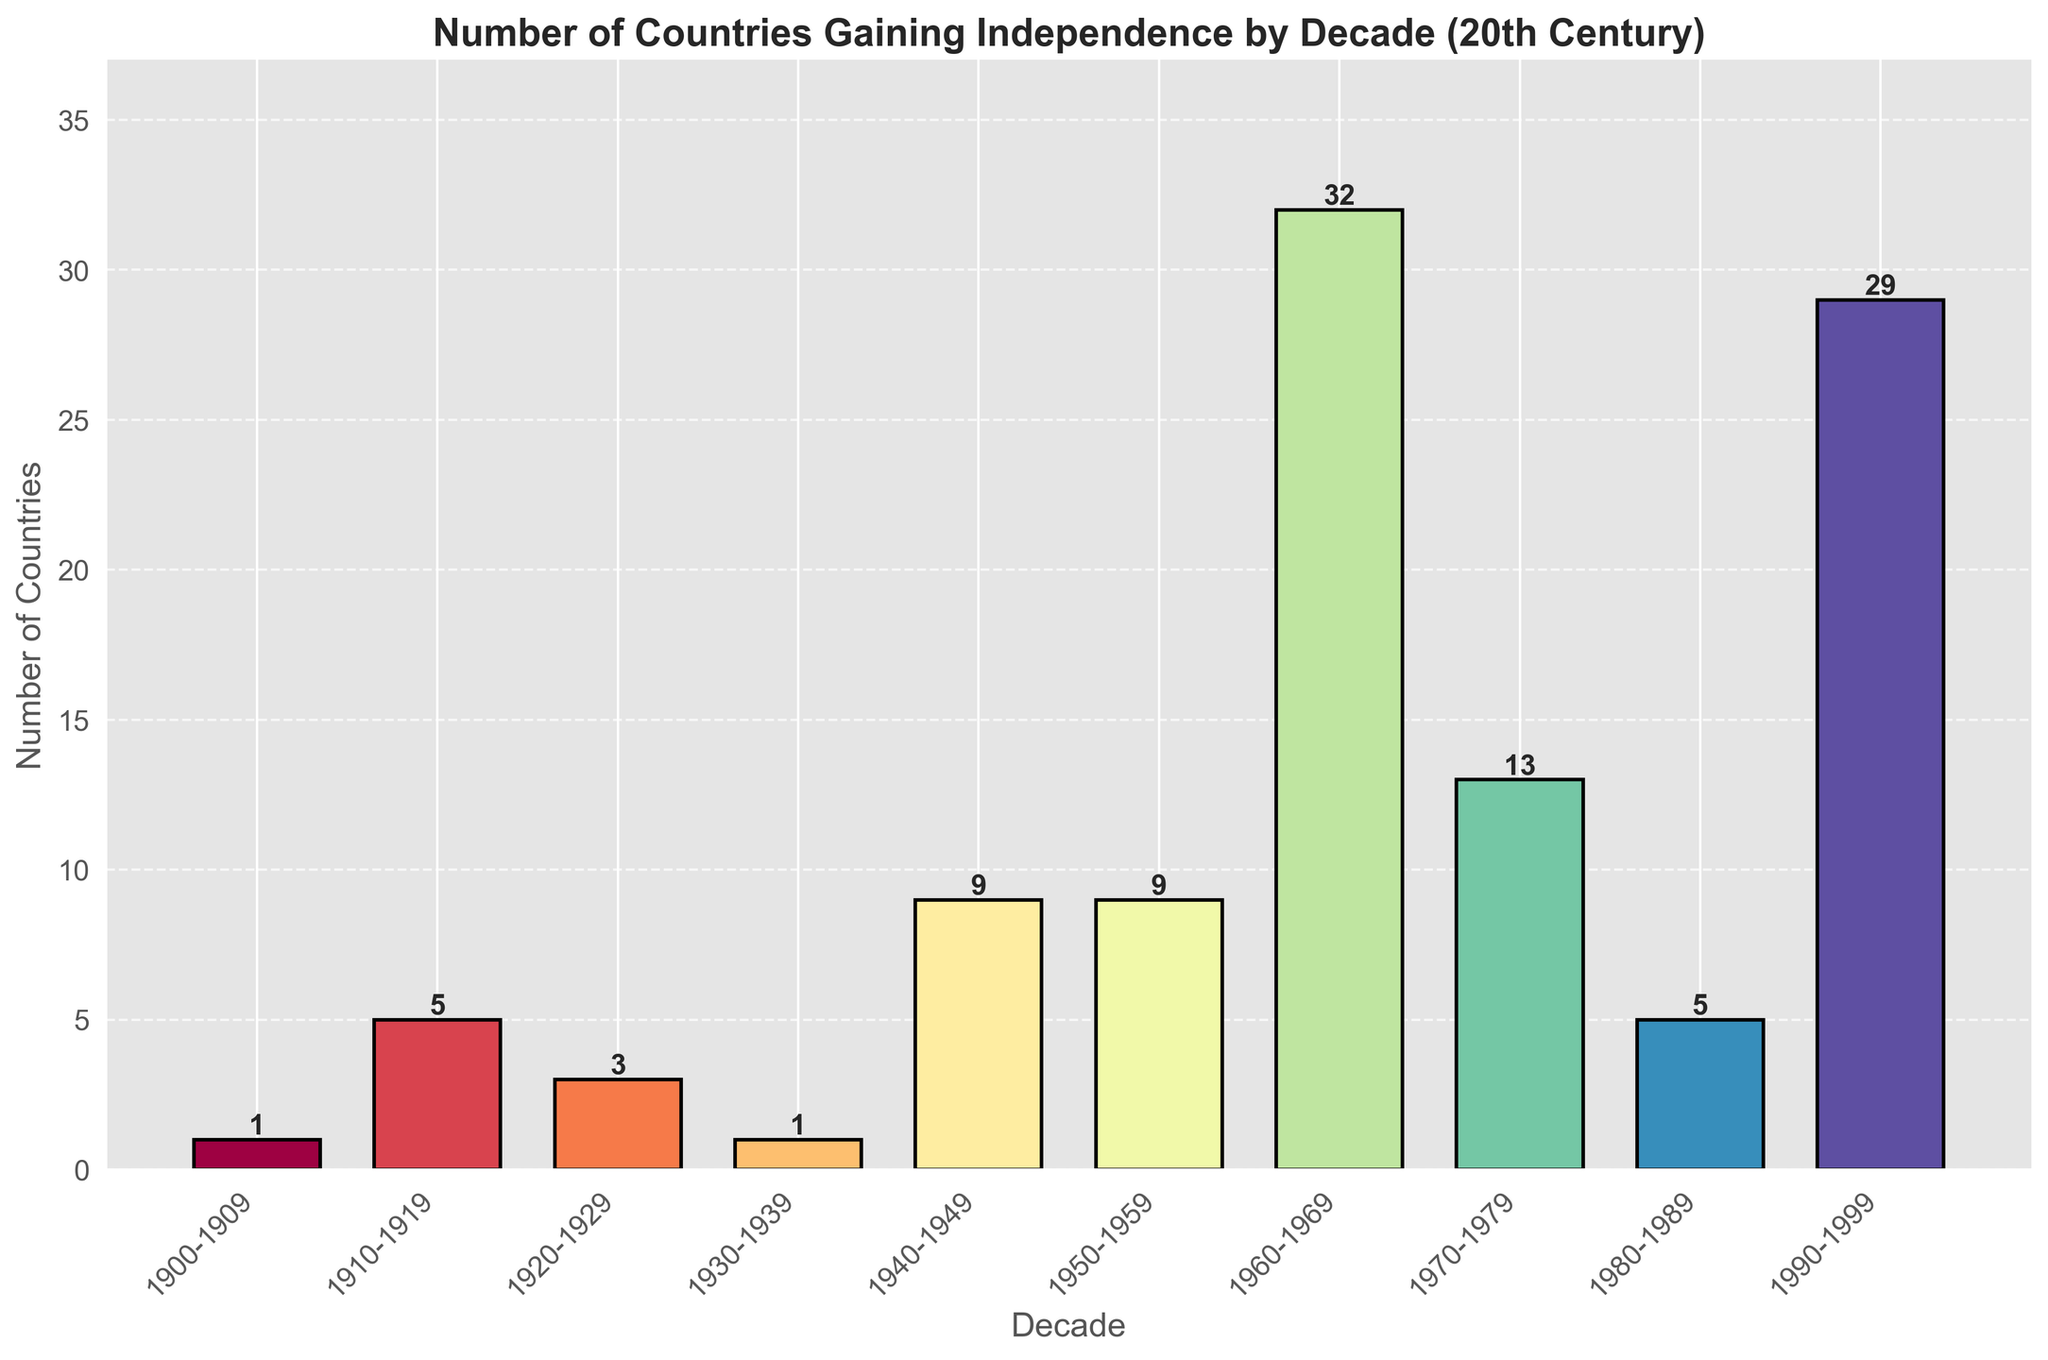How many countries gained independence between the 1980s and 1990s combined? Add the number of countries from 1980-1989 (5) and from 1990-1999 (29): 5 + 29 = 34
Answer: 34 Which decade had the highest number of countries gaining independence? The tallest bar represents the 1960-1969 decade with 32 countries gaining independence.
Answer: 1960-1969 How many more countries gained independence in the 1960s compared to the 1950s? Subtract the number of countries in 1950-1959 (9) from the number in 1960-1969 (32): 32 - 9 = 23
Answer: 23 During which decades did the number of countries gaining independence more than double compared to the previous decade? Compare each decade to its preceding decade:
- 1940-1949 (9) compared to 1930-1939 (1): Yes, increased by 8
- 1960-1969 (32) compared to 1950-1959 (9): Yes, increased by 23
Answer: 1940-1949, 1960-1969 What is the average number of countries gaining independence per decade in the first half of the 20th century (1900-1949)? Sum the numbers for 1900-1909 (1), 1910-1919 (5), 1920-1929 (3), 1930-1939 (1), and 1940-1949 (9): 1 + 5 + 3 + 1 + 9 = 19. Divide by 5 decades: 19 / 5 = 3.8
Answer: 3.8 Which decade saw the smallest number of countries gaining independence? The shortest bars represent both 1900-1909 and 1930-1939 with 1 country each.
Answer: 1900-1909, 1930-1939 In which decades did the number of countries gaining independence remain the same? Compare the relevant decades: 
- 1940-1949 (9) and 1950-1959 (9) are the same.
Answer: 1940-1949, 1950-1959 How many countries in total gained independence in the 20th century according to the data? Sum all the given numbers: 1 + 5 + 3 + 1 + 9 + 9 + 32 + 13 + 5 + 29 = 107
Answer: 107 What's the visual difference between the bars representing the 1960s and the 1980s? The bar for 1960-1969 is notably taller than the bar for 1980-1989, indicating more countries (32 vs. 5) gained independence in the 1960s compared to the 1980s.
Answer: Taller How much taller is the bar representing the 1960s compared to the 1920s? Subtract the height of the 1920-1929 bar (3) from the 1960-1969 bar (32): 32 - 3 = 29
Answer: 29 